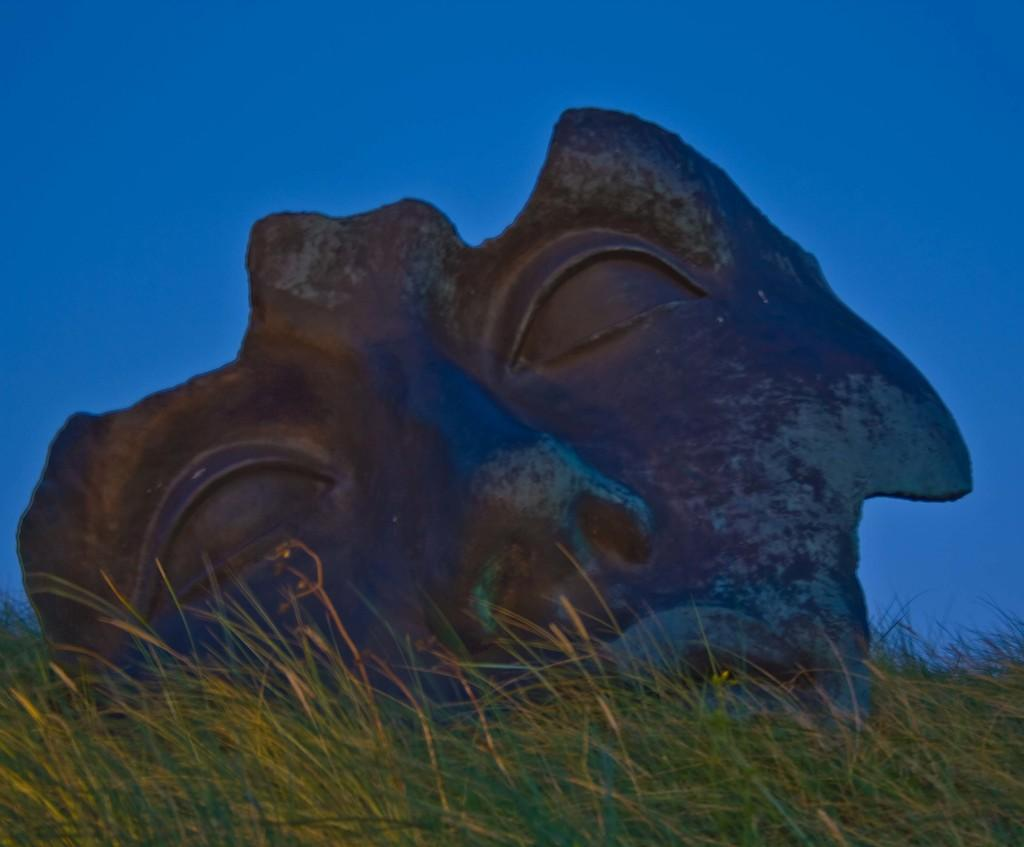What is the main subject of the image? There is a sculpture in the image. What type of natural environment is present in the image? There is grass in the image. What can be seen in the background of the image? The sky is visible in the image. What type of jeans is the sculpture wearing in the image? The sculpture is not wearing jeans, as it is an inanimate object and not a person. 